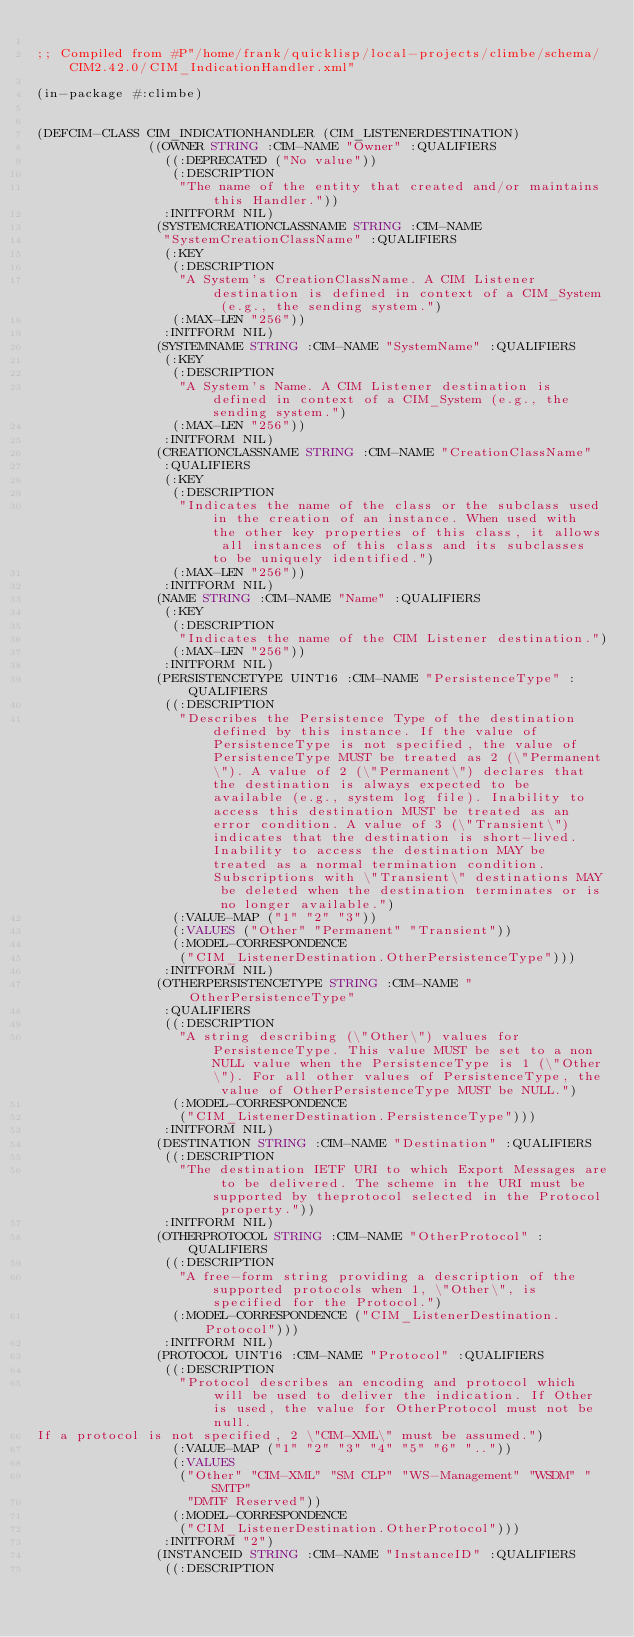Convert code to text. <code><loc_0><loc_0><loc_500><loc_500><_Lisp_>
;; Compiled from #P"/home/frank/quicklisp/local-projects/climbe/schema/CIM2.42.0/CIM_IndicationHandler.xml"

(in-package #:climbe)


(DEFCIM-CLASS CIM_INDICATIONHANDLER (CIM_LISTENERDESTINATION)
              ((OWNER STRING :CIM-NAME "Owner" :QUALIFIERS
                ((:DEPRECATED ("No value"))
                 (:DESCRIPTION
                  "The name of the entity that created and/or maintains this Handler."))
                :INITFORM NIL)
               (SYSTEMCREATIONCLASSNAME STRING :CIM-NAME
                "SystemCreationClassName" :QUALIFIERS
                (:KEY
                 (:DESCRIPTION
                  "A System's CreationClassName. A CIM Listener destination is defined in context of a CIM_System (e.g., the sending system.")
                 (:MAX-LEN "256"))
                :INITFORM NIL)
               (SYSTEMNAME STRING :CIM-NAME "SystemName" :QUALIFIERS
                (:KEY
                 (:DESCRIPTION
                  "A System's Name. A CIM Listener destination is defined in context of a CIM_System (e.g., the sending system.")
                 (:MAX-LEN "256"))
                :INITFORM NIL)
               (CREATIONCLASSNAME STRING :CIM-NAME "CreationClassName"
                :QUALIFIERS
                (:KEY
                 (:DESCRIPTION
                  "Indicates the name of the class or the subclass used in the creation of an instance. When used with the other key properties of this class, it allows all instances of this class and its subclasses to be uniquely identified.")
                 (:MAX-LEN "256"))
                :INITFORM NIL)
               (NAME STRING :CIM-NAME "Name" :QUALIFIERS
                (:KEY
                 (:DESCRIPTION
                  "Indicates the name of the CIM Listener destination.")
                 (:MAX-LEN "256"))
                :INITFORM NIL)
               (PERSISTENCETYPE UINT16 :CIM-NAME "PersistenceType" :QUALIFIERS
                ((:DESCRIPTION
                  "Describes the Persistence Type of the destination defined by this instance. If the value of PersistenceType is not specified, the value of PersistenceType MUST be treated as 2 (\"Permanent\"). A value of 2 (\"Permanent\") declares that the destination is always expected to be available (e.g., system log file). Inability to access this destination MUST be treated as an error condition. A value of 3 (\"Transient\") indicates that the destination is short-lived. Inability to access the destination MAY be treated as a normal termination condition. Subscriptions with \"Transient\" destinations MAY be deleted when the destination terminates or is no longer available.")
                 (:VALUE-MAP ("1" "2" "3"))
                 (:VALUES ("Other" "Permanent" "Transient"))
                 (:MODEL-CORRESPONDENCE
                  ("CIM_ListenerDestination.OtherPersistenceType")))
                :INITFORM NIL)
               (OTHERPERSISTENCETYPE STRING :CIM-NAME "OtherPersistenceType"
                :QUALIFIERS
                ((:DESCRIPTION
                  "A string describing (\"Other\") values for PersistenceType. This value MUST be set to a non NULL value when the PersistenceType is 1 (\"Other\"). For all other values of PersistenceType, the value of OtherPersistenceType MUST be NULL.")
                 (:MODEL-CORRESPONDENCE
                  ("CIM_ListenerDestination.PersistenceType")))
                :INITFORM NIL)
               (DESTINATION STRING :CIM-NAME "Destination" :QUALIFIERS
                ((:DESCRIPTION
                  "The destination IETF URI to which Export Messages are to be delivered. The scheme in the URI must be supported by theprotocol selected in the Protocol property."))
                :INITFORM NIL)
               (OTHERPROTOCOL STRING :CIM-NAME "OtherProtocol" :QUALIFIERS
                ((:DESCRIPTION
                  "A free-form string providing a description of the supported protocols when 1, \"Other\", is specified for the Protocol.")
                 (:MODEL-CORRESPONDENCE ("CIM_ListenerDestination.Protocol")))
                :INITFORM NIL)
               (PROTOCOL UINT16 :CIM-NAME "Protocol" :QUALIFIERS
                ((:DESCRIPTION
                  "Protocol describes an encoding and protocol which will be used to deliver the indication. If Other is used, the value for OtherProtocol must not be null.
If a protocol is not specified, 2 \"CIM-XML\" must be assumed.")
                 (:VALUE-MAP ("1" "2" "3" "4" "5" "6" ".."))
                 (:VALUES
                  ("Other" "CIM-XML" "SM CLP" "WS-Management" "WSDM" "SMTP"
                   "DMTF Reserved"))
                 (:MODEL-CORRESPONDENCE
                  ("CIM_ListenerDestination.OtherProtocol")))
                :INITFORM "2")
               (INSTANCEID STRING :CIM-NAME "InstanceID" :QUALIFIERS
                ((:DESCRIPTION</code> 